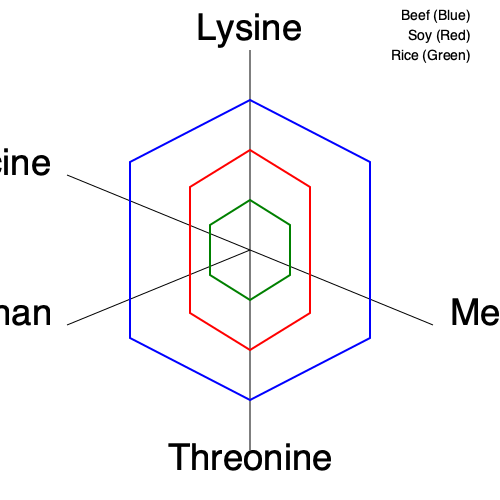Analyze the radar chart depicting the essential amino acid profiles of beef, soy, and rice. Which food source has the highest overall protein quality, and what specific amino acid appears to be limiting in rice compared to the other sources? To answer this question, we need to analyze the radar chart and understand the concept of protein quality and limiting amino acids. Let's break it down step-by-step:

1. Protein quality assessment:
   - Protein quality is determined by the presence and balance of essential amino acids.
   - A larger area on the radar chart indicates a more complete amino acid profile.

2. Analyzing the chart:
   - Blue polygon (Beef): Covers the largest area, extending furthest on most axes.
   - Red polygon (Soy): Covers a slightly smaller area than beef, but still substantial.
   - Green polygon (Rice): Covers the smallest area, with notable deficiencies in some amino acids.

3. Comparing protein quality:
   - Beef has the most balanced and abundant essential amino acid profile.
   - Soy is a close second, with a relatively well-balanced profile.
   - Rice has the least balanced profile among the three.

4. Identifying the limiting amino acid in rice:
   - A limiting amino acid is the essential amino acid present in the lowest quantity relative to needs.
   - In the chart, the axis where the green polygon (rice) is furthest from the outer edge compared to beef and soy is lysine.

5. Conclusion:
   - Beef has the highest overall protein quality due to its more complete amino acid profile.
   - Lysine appears to be the limiting amino acid in rice, as it shows the most significant deficiency compared to beef and soy.
Answer: Beef has the highest protein quality; lysine is limiting in rice. 